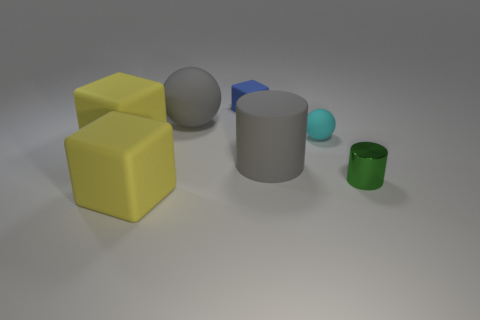Are there any other things that have the same material as the green thing?
Offer a very short reply. No. Do the big object that is to the right of the small cube and the small blue matte object have the same shape?
Keep it short and to the point. No. What is the large sphere made of?
Offer a very short reply. Rubber. What shape is the gray matte object to the left of the cube that is right of the ball behind the cyan rubber ball?
Ensure brevity in your answer.  Sphere. What number of other objects are there of the same shape as the tiny green metal thing?
Your answer should be compact. 1. There is a small cube; is it the same color as the shiny cylinder on the right side of the blue rubber block?
Keep it short and to the point. No. How many small metal cylinders are there?
Ensure brevity in your answer.  1. How many things are either big rubber cylinders or yellow matte things?
Your response must be concise. 3. There is a matte object that is the same color as the big rubber sphere; what size is it?
Your answer should be very brief. Large. Are there any tiny metallic cylinders in front of the small green metallic thing?
Give a very brief answer. No. 